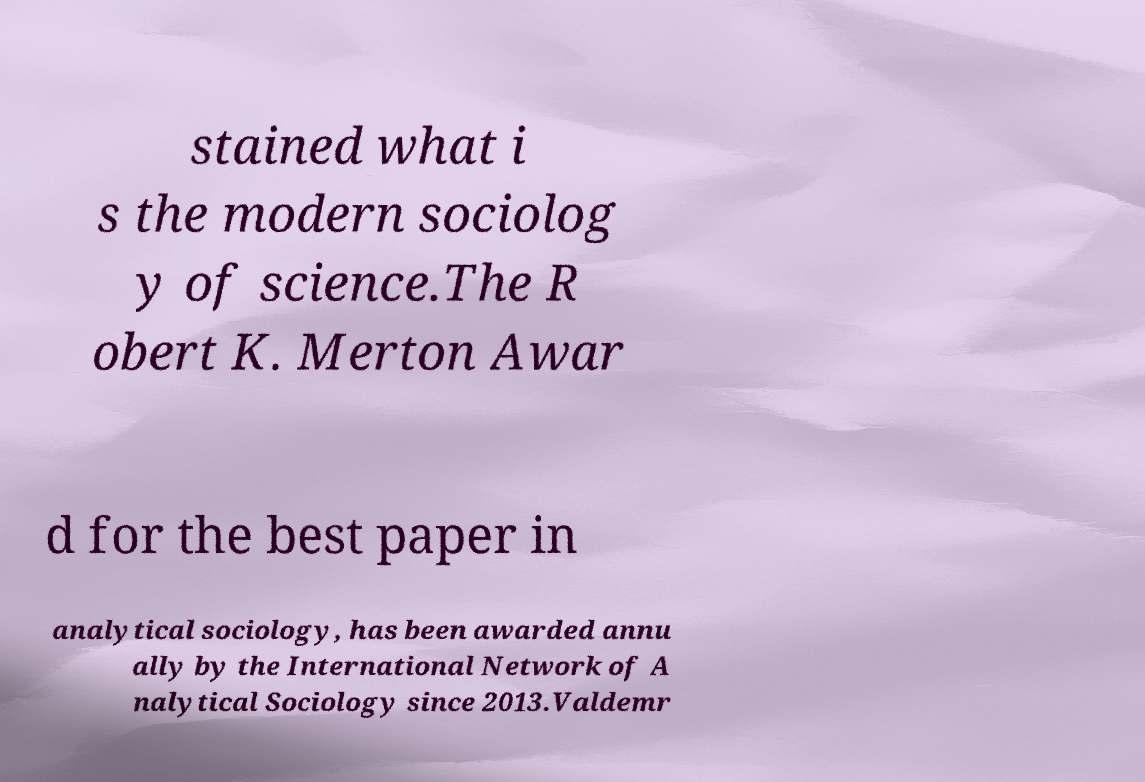Can you read and provide the text displayed in the image?This photo seems to have some interesting text. Can you extract and type it out for me? stained what i s the modern sociolog y of science.The R obert K. Merton Awar d for the best paper in analytical sociology, has been awarded annu ally by the International Network of A nalytical Sociology since 2013.Valdemr 